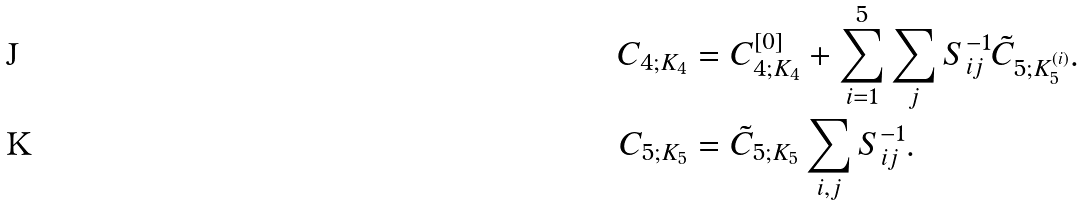<formula> <loc_0><loc_0><loc_500><loc_500>C _ { 4 ; K _ { 4 } } & = C _ { 4 ; K _ { 4 } } ^ { [ 0 ] } + \sum _ { i = 1 } ^ { 5 } \sum _ { j } S ^ { - 1 } _ { i j } \tilde { C } _ { 5 ; K _ { 5 } ^ { ( i ) } } . \\ C _ { 5 ; K _ { 5 } } & = \tilde { C } _ { 5 ; K _ { 5 } } \sum _ { i , j } S ^ { - 1 } _ { i j } .</formula> 